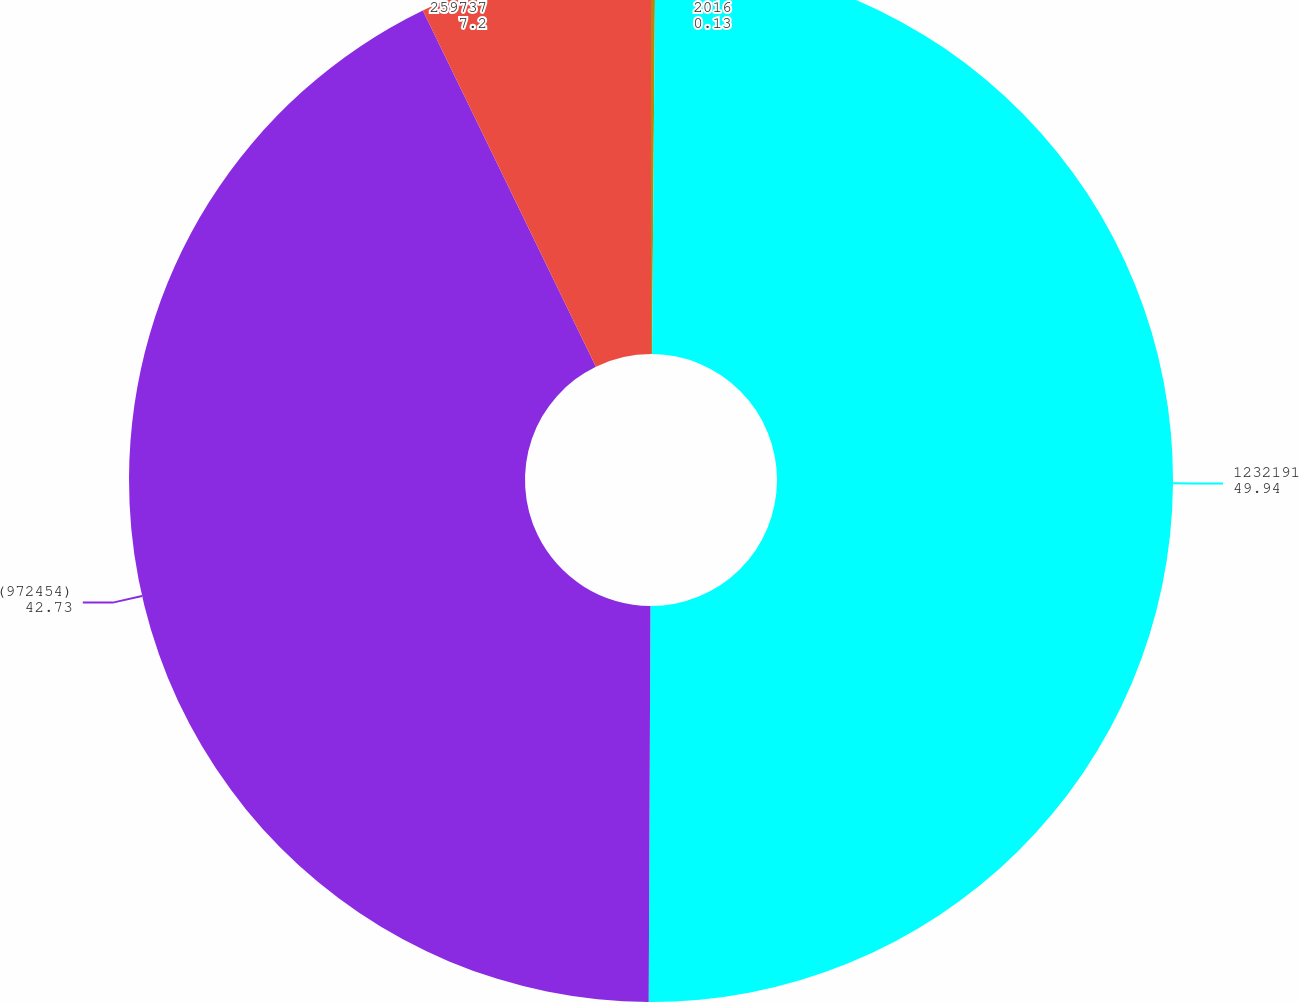<chart> <loc_0><loc_0><loc_500><loc_500><pie_chart><fcel>2016<fcel>1232191<fcel>(972454)<fcel>259737<nl><fcel>0.13%<fcel>49.94%<fcel>42.73%<fcel>7.2%<nl></chart> 